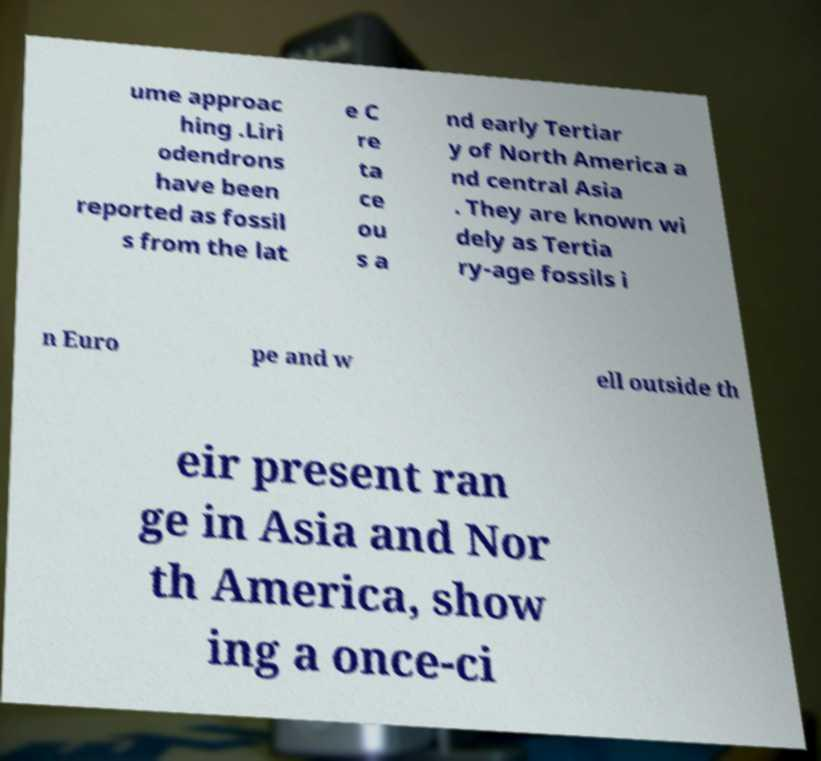Can you accurately transcribe the text from the provided image for me? ume approac hing .Liri odendrons have been reported as fossil s from the lat e C re ta ce ou s a nd early Tertiar y of North America a nd central Asia . They are known wi dely as Tertia ry-age fossils i n Euro pe and w ell outside th eir present ran ge in Asia and Nor th America, show ing a once-ci 